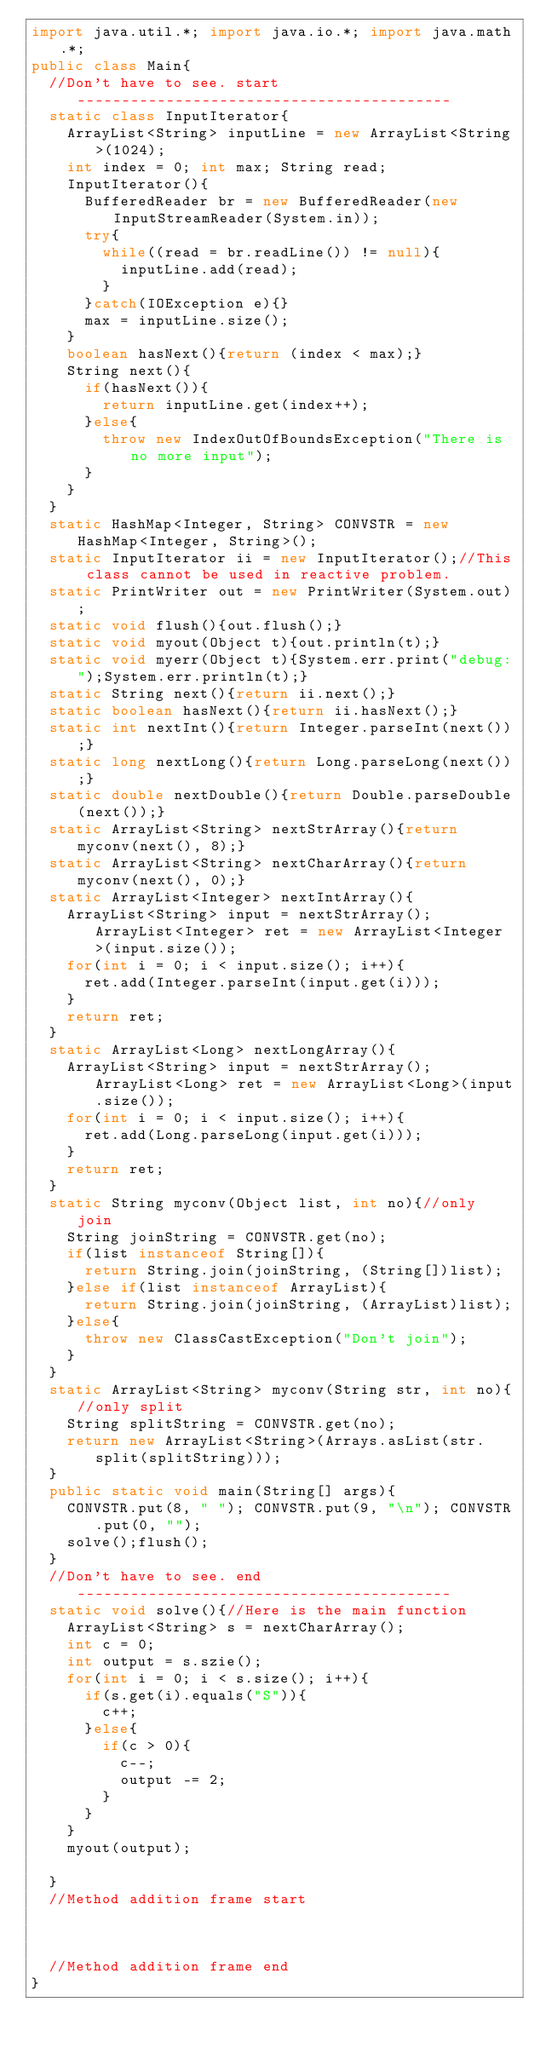Convert code to text. <code><loc_0><loc_0><loc_500><loc_500><_Java_>import java.util.*; import java.io.*; import java.math.*;
public class Main{
	//Don't have to see. start------------------------------------------
	static class InputIterator{
		ArrayList<String> inputLine = new ArrayList<String>(1024);
		int index = 0; int max; String read;
		InputIterator(){
			BufferedReader br = new BufferedReader(new InputStreamReader(System.in));
			try{
				while((read = br.readLine()) != null){
					inputLine.add(read);
				}
			}catch(IOException e){}
			max = inputLine.size();
		}
		boolean hasNext(){return (index < max);}
		String next(){
			if(hasNext()){
				return inputLine.get(index++);
			}else{
				throw new IndexOutOfBoundsException("There is no more input");
			}
		}
	}
	static HashMap<Integer, String> CONVSTR = new HashMap<Integer, String>();
	static InputIterator ii = new InputIterator();//This class cannot be used in reactive problem.
	static PrintWriter out = new PrintWriter(System.out);
	static void flush(){out.flush();}
	static void myout(Object t){out.println(t);}
	static void myerr(Object t){System.err.print("debug:");System.err.println(t);}
	static String next(){return ii.next();}
	static boolean hasNext(){return ii.hasNext();}
	static int nextInt(){return Integer.parseInt(next());}
	static long nextLong(){return Long.parseLong(next());}
	static double nextDouble(){return Double.parseDouble(next());}
	static ArrayList<String> nextStrArray(){return myconv(next(), 8);}
	static ArrayList<String> nextCharArray(){return myconv(next(), 0);}
	static ArrayList<Integer> nextIntArray(){
		ArrayList<String> input = nextStrArray(); ArrayList<Integer> ret = new ArrayList<Integer>(input.size());
		for(int i = 0; i < input.size(); i++){
			ret.add(Integer.parseInt(input.get(i)));
		}
		return ret;
	}
	static ArrayList<Long> nextLongArray(){
		ArrayList<String> input = nextStrArray(); ArrayList<Long> ret = new ArrayList<Long>(input.size());
		for(int i = 0; i < input.size(); i++){
			ret.add(Long.parseLong(input.get(i)));
		}
		return ret;
	}
	static String myconv(Object list, int no){//only join
		String joinString = CONVSTR.get(no);
		if(list instanceof String[]){
			return String.join(joinString, (String[])list);
		}else if(list instanceof ArrayList){
			return String.join(joinString, (ArrayList)list);
		}else{
			throw new ClassCastException("Don't join");
		}
	}
	static ArrayList<String> myconv(String str, int no){//only split
		String splitString = CONVSTR.get(no);
		return new ArrayList<String>(Arrays.asList(str.split(splitString)));
	}
	public static void main(String[] args){
		CONVSTR.put(8, " "); CONVSTR.put(9, "\n"); CONVSTR.put(0, "");
		solve();flush();
	}
	//Don't have to see. end------------------------------------------
	static void solve(){//Here is the main function
		ArrayList<String> s = nextCharArray();
		int c = 0;
		int output = s.szie();
		for(int i = 0; i < s.size(); i++){
			if(s.get(i).equals("S")){
				c++;
			}else{
				if(c > 0){
					c--;
					output -= 2;
				}
			}
		}
		myout(output);

	}
	//Method addition frame start



	//Method addition frame end
}
</code> 